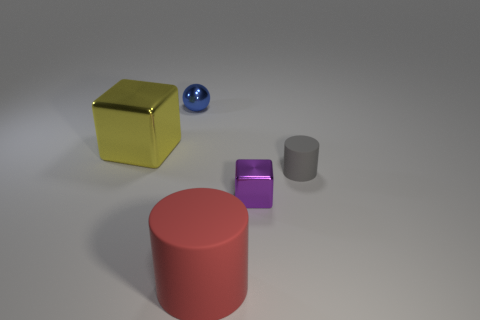Add 1 cyan cylinders. How many objects exist? 6 Subtract all spheres. How many objects are left? 4 Add 3 tiny purple cubes. How many tiny purple cubes are left? 4 Add 3 purple metallic things. How many purple metallic things exist? 4 Subtract 0 cyan cubes. How many objects are left? 5 Subtract all tiny shiny blocks. Subtract all big rubber cylinders. How many objects are left? 3 